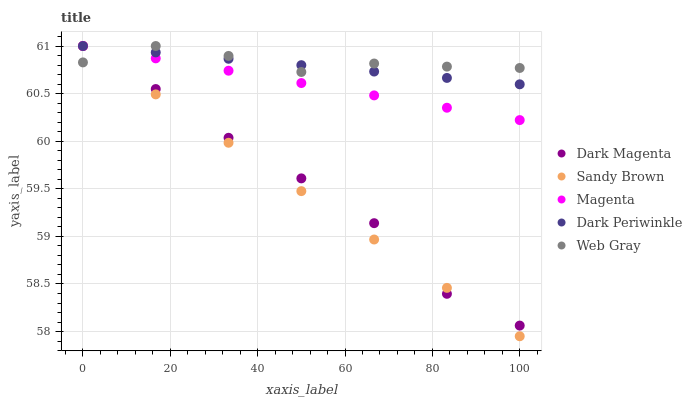Does Sandy Brown have the minimum area under the curve?
Answer yes or no. Yes. Does Web Gray have the maximum area under the curve?
Answer yes or no. Yes. Does Web Gray have the minimum area under the curve?
Answer yes or no. No. Does Sandy Brown have the maximum area under the curve?
Answer yes or no. No. Is Magenta the smoothest?
Answer yes or no. Yes. Is Dark Magenta the roughest?
Answer yes or no. Yes. Is Web Gray the smoothest?
Answer yes or no. No. Is Web Gray the roughest?
Answer yes or no. No. Does Sandy Brown have the lowest value?
Answer yes or no. Yes. Does Web Gray have the lowest value?
Answer yes or no. No. Does Dark Periwinkle have the highest value?
Answer yes or no. Yes. Does Dark Magenta intersect Sandy Brown?
Answer yes or no. Yes. Is Dark Magenta less than Sandy Brown?
Answer yes or no. No. Is Dark Magenta greater than Sandy Brown?
Answer yes or no. No. 